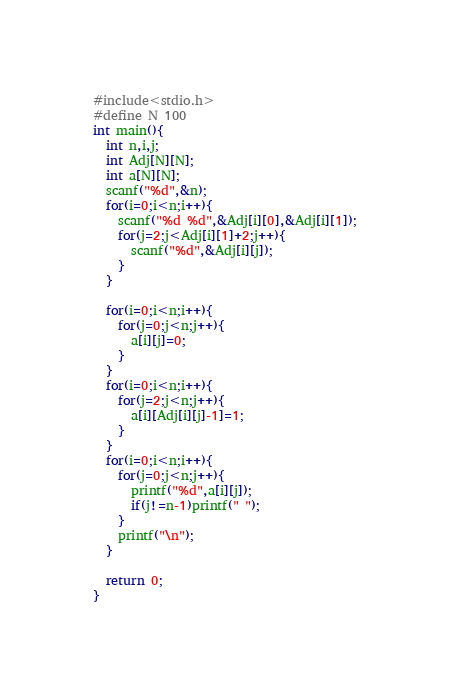<code> <loc_0><loc_0><loc_500><loc_500><_C_>#include<stdio.h>
#define N 100
int main(){
  int n,i,j;
  int Adj[N][N];
  int a[N][N];
  scanf("%d",&n);
  for(i=0;i<n;i++){
    scanf("%d %d",&Adj[i][0],&Adj[i][1]);
    for(j=2;j<Adj[i][1]+2;j++){
      scanf("%d",&Adj[i][j]);
    }
  }
  
  for(i=0;i<n;i++){
    for(j=0;j<n;j++){
      a[i][j]=0;
    }
  }
  for(i=0;i<n;i++){
    for(j=2;j<n;j++){
      a[i][Adj[i][j]-1]=1;
    }
  }
  for(i=0;i<n;i++){
    for(j=0;j<n;j++){
      printf("%d",a[i][j]);
      if(j!=n-1)printf(" ");
    }
    printf("\n");
  }

  return 0;
}</code> 